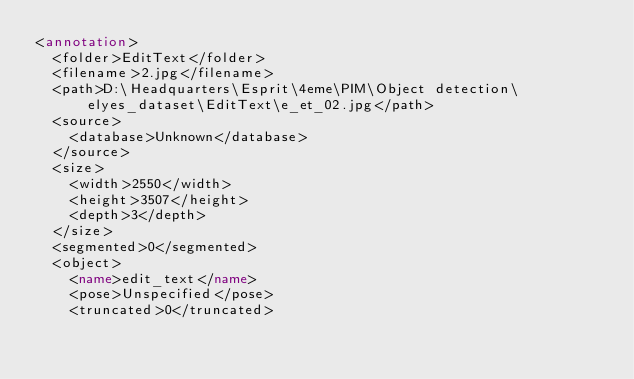<code> <loc_0><loc_0><loc_500><loc_500><_XML_><annotation>
	<folder>EditText</folder>
	<filename>2.jpg</filename>
	<path>D:\Headquarters\Esprit\4eme\PIM\Object detection\elyes_dataset\EditText\e_et_02.jpg</path>
	<source>
		<database>Unknown</database>
	</source>
	<size>
		<width>2550</width>
		<height>3507</height>
		<depth>3</depth>
	</size>
	<segmented>0</segmented>
	<object>
		<name>edit_text</name>
		<pose>Unspecified</pose>
		<truncated>0</truncated></code> 